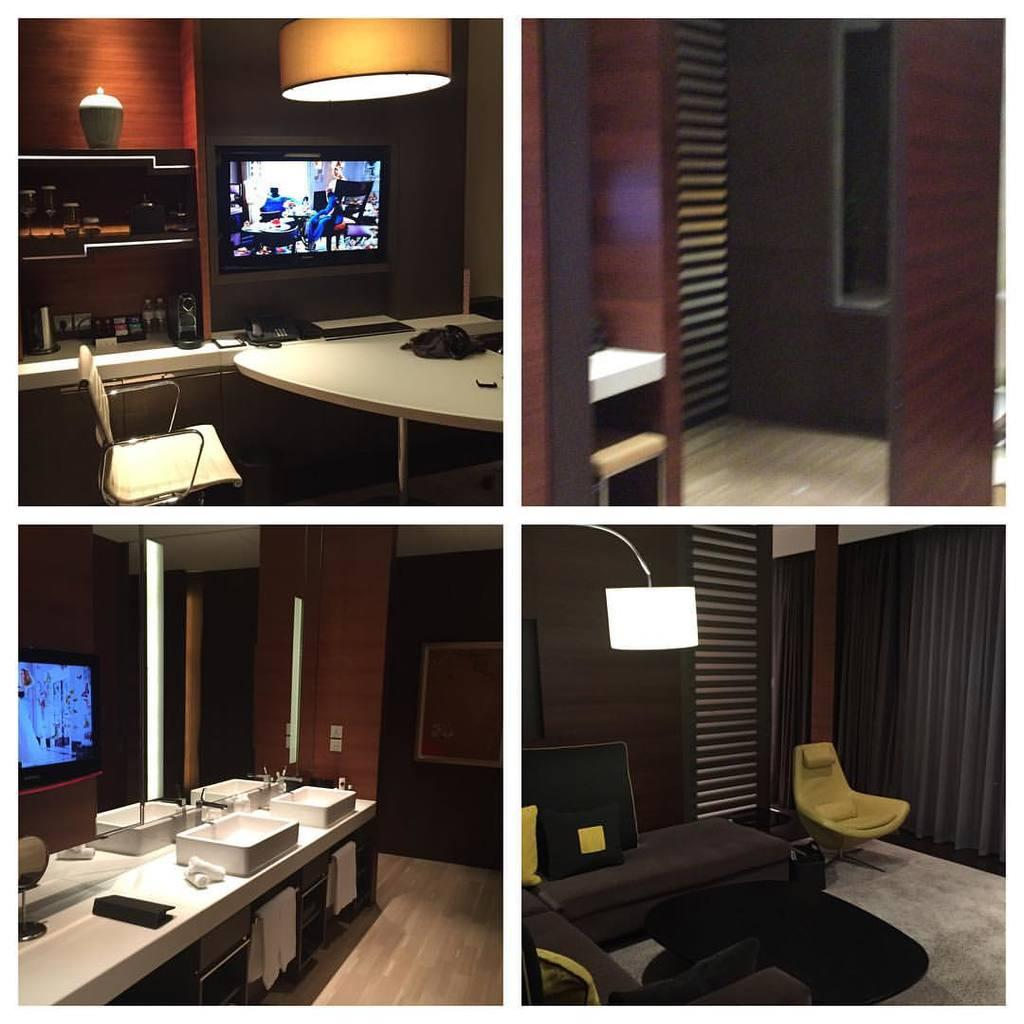What electronic device is present in the image? There is a television in the image. What type of lighting is visible in the image? There is a lamp in the image. What piece of furniture is present in the image that can be used for placing objects? There is a table in the image. What type of seating is present in the image? There are chairs in the image. What type of objects are present in the image that are typically used for arranging and organizing a room? There is furniture in the image. What type of leather is used to make the yoke in the image? There is no yoke present in the image, so it is not possible to determine the type of leather used. 